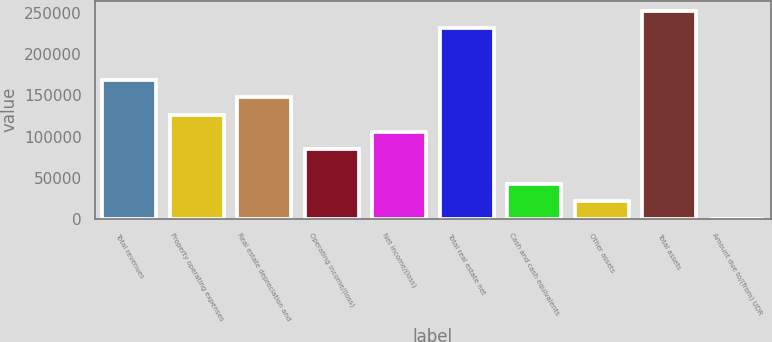Convert chart. <chart><loc_0><loc_0><loc_500><loc_500><bar_chart><fcel>Total revenues<fcel>Property operating expenses<fcel>Real estate depreciation and<fcel>Operating income/(loss)<fcel>Net income/(loss)<fcel>Total real estate net<fcel>Cash and cash equivalents<fcel>Other assets<fcel>Total assets<fcel>Amount due to/(from) UDR<nl><fcel>168421<fcel>126423<fcel>147422<fcel>84425<fcel>105424<fcel>231418<fcel>42427<fcel>21428<fcel>252417<fcel>429<nl></chart> 